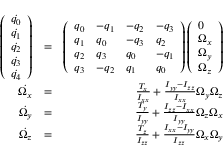Convert formula to latex. <formula><loc_0><loc_0><loc_500><loc_500>\begin{array} { r l r } { \left ( \begin{array} { l } { \dot { q _ { 0 } } } \\ { \dot { q _ { 1 } } } \\ { \dot { q _ { 2 } } } \\ { \dot { q _ { 3 } } } \\ { \dot { q _ { 4 } } } \end{array} \right ) } & { = } & { \left ( \begin{array} { l l l l } { q _ { 0 } } & { - q _ { 1 } } & { - q _ { 2 } } & { - q _ { 3 } } \\ { q _ { 1 } } & { q _ { 0 } } & { - q _ { 3 } } & { q _ { 2 } } \\ { q _ { 2 } } & { q _ { 3 } } & { q _ { 0 } } & { - q _ { 1 } } \\ { q _ { 3 } } & { - q _ { 2 } } & { q _ { 1 } } & { q _ { 0 } } \end{array} \right ) \left ( \begin{array} { l } { 0 } \\ { \Omega _ { x } } \\ { \Omega _ { y } } \\ { \Omega _ { z } } \end{array} \right ) } \\ { \dot { \Omega _ { x } } } & { = } & { \frac { T _ { x } } { I _ { x x } } + \frac { I _ { y y } - I _ { z z } } { I _ { x x } } \Omega _ { y } \Omega _ { z } } \\ { \dot { \Omega _ { y } } } & { = } & { \frac { T _ { y } } { I _ { y y } } + \frac { I _ { z z } - I _ { x x } } { I _ { y y } } \Omega _ { z } \Omega _ { x } } \\ { \dot { \Omega _ { z } } } & { = } & { \frac { T _ { z } } { I _ { z z } } + \frac { I _ { x x } - I _ { y y } } { I _ { z z } } \Omega _ { x } \Omega _ { y } } \end{array}</formula> 